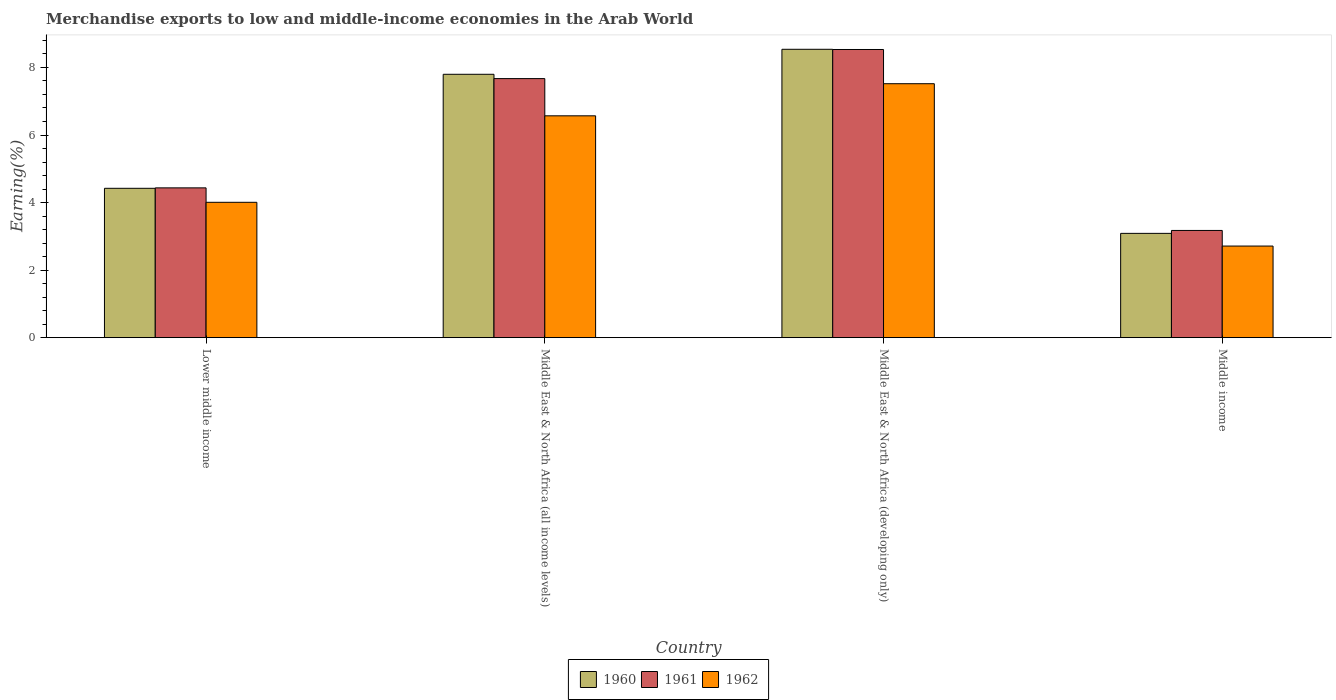How many different coloured bars are there?
Provide a succinct answer. 3. Are the number of bars per tick equal to the number of legend labels?
Your answer should be compact. Yes. Are the number of bars on each tick of the X-axis equal?
Give a very brief answer. Yes. What is the label of the 4th group of bars from the left?
Keep it short and to the point. Middle income. What is the percentage of amount earned from merchandise exports in 1961 in Middle income?
Offer a very short reply. 3.17. Across all countries, what is the maximum percentage of amount earned from merchandise exports in 1960?
Offer a very short reply. 8.54. Across all countries, what is the minimum percentage of amount earned from merchandise exports in 1961?
Give a very brief answer. 3.17. In which country was the percentage of amount earned from merchandise exports in 1961 maximum?
Keep it short and to the point. Middle East & North Africa (developing only). In which country was the percentage of amount earned from merchandise exports in 1960 minimum?
Provide a short and direct response. Middle income. What is the total percentage of amount earned from merchandise exports in 1961 in the graph?
Make the answer very short. 23.81. What is the difference between the percentage of amount earned from merchandise exports in 1960 in Lower middle income and that in Middle East & North Africa (all income levels)?
Make the answer very short. -3.38. What is the difference between the percentage of amount earned from merchandise exports in 1961 in Middle East & North Africa (all income levels) and the percentage of amount earned from merchandise exports in 1962 in Lower middle income?
Your answer should be very brief. 3.66. What is the average percentage of amount earned from merchandise exports in 1962 per country?
Provide a succinct answer. 5.2. What is the difference between the percentage of amount earned from merchandise exports of/in 1961 and percentage of amount earned from merchandise exports of/in 1960 in Middle East & North Africa (developing only)?
Provide a succinct answer. -0.01. In how many countries, is the percentage of amount earned from merchandise exports in 1962 greater than 5.6 %?
Your answer should be very brief. 2. What is the ratio of the percentage of amount earned from merchandise exports in 1962 in Middle East & North Africa (all income levels) to that in Middle East & North Africa (developing only)?
Your answer should be very brief. 0.87. Is the percentage of amount earned from merchandise exports in 1960 in Middle East & North Africa (all income levels) less than that in Middle East & North Africa (developing only)?
Offer a very short reply. Yes. Is the difference between the percentage of amount earned from merchandise exports in 1961 in Middle East & North Africa (developing only) and Middle income greater than the difference between the percentage of amount earned from merchandise exports in 1960 in Middle East & North Africa (developing only) and Middle income?
Your answer should be compact. No. What is the difference between the highest and the second highest percentage of amount earned from merchandise exports in 1961?
Offer a terse response. 4.1. What is the difference between the highest and the lowest percentage of amount earned from merchandise exports in 1960?
Offer a very short reply. 5.45. In how many countries, is the percentage of amount earned from merchandise exports in 1960 greater than the average percentage of amount earned from merchandise exports in 1960 taken over all countries?
Provide a succinct answer. 2. Is the sum of the percentage of amount earned from merchandise exports in 1960 in Middle East & North Africa (all income levels) and Middle income greater than the maximum percentage of amount earned from merchandise exports in 1961 across all countries?
Your answer should be very brief. Yes. What does the 3rd bar from the right in Middle East & North Africa (developing only) represents?
Your answer should be very brief. 1960. How many bars are there?
Ensure brevity in your answer.  12. Are all the bars in the graph horizontal?
Your answer should be compact. No. How many countries are there in the graph?
Keep it short and to the point. 4. What is the difference between two consecutive major ticks on the Y-axis?
Give a very brief answer. 2. Does the graph contain any zero values?
Keep it short and to the point. No. Does the graph contain grids?
Your answer should be compact. No. Where does the legend appear in the graph?
Provide a short and direct response. Bottom center. How many legend labels are there?
Provide a short and direct response. 3. How are the legend labels stacked?
Your response must be concise. Horizontal. What is the title of the graph?
Offer a very short reply. Merchandise exports to low and middle-income economies in the Arab World. Does "1989" appear as one of the legend labels in the graph?
Your answer should be very brief. No. What is the label or title of the X-axis?
Offer a terse response. Country. What is the label or title of the Y-axis?
Your answer should be very brief. Earning(%). What is the Earning(%) of 1960 in Lower middle income?
Offer a very short reply. 4.42. What is the Earning(%) in 1961 in Lower middle income?
Your response must be concise. 4.43. What is the Earning(%) in 1962 in Lower middle income?
Provide a succinct answer. 4.01. What is the Earning(%) of 1960 in Middle East & North Africa (all income levels)?
Give a very brief answer. 7.8. What is the Earning(%) in 1961 in Middle East & North Africa (all income levels)?
Offer a terse response. 7.67. What is the Earning(%) of 1962 in Middle East & North Africa (all income levels)?
Ensure brevity in your answer.  6.57. What is the Earning(%) in 1960 in Middle East & North Africa (developing only)?
Provide a succinct answer. 8.54. What is the Earning(%) in 1961 in Middle East & North Africa (developing only)?
Keep it short and to the point. 8.53. What is the Earning(%) of 1962 in Middle East & North Africa (developing only)?
Give a very brief answer. 7.52. What is the Earning(%) of 1960 in Middle income?
Provide a succinct answer. 3.09. What is the Earning(%) of 1961 in Middle income?
Offer a terse response. 3.17. What is the Earning(%) of 1962 in Middle income?
Make the answer very short. 2.71. Across all countries, what is the maximum Earning(%) in 1960?
Your answer should be very brief. 8.54. Across all countries, what is the maximum Earning(%) in 1961?
Provide a succinct answer. 8.53. Across all countries, what is the maximum Earning(%) in 1962?
Offer a very short reply. 7.52. Across all countries, what is the minimum Earning(%) in 1960?
Provide a succinct answer. 3.09. Across all countries, what is the minimum Earning(%) in 1961?
Make the answer very short. 3.17. Across all countries, what is the minimum Earning(%) in 1962?
Give a very brief answer. 2.71. What is the total Earning(%) of 1960 in the graph?
Ensure brevity in your answer.  23.85. What is the total Earning(%) of 1961 in the graph?
Your answer should be compact. 23.81. What is the total Earning(%) of 1962 in the graph?
Give a very brief answer. 20.81. What is the difference between the Earning(%) in 1960 in Lower middle income and that in Middle East & North Africa (all income levels)?
Give a very brief answer. -3.38. What is the difference between the Earning(%) of 1961 in Lower middle income and that in Middle East & North Africa (all income levels)?
Offer a terse response. -3.23. What is the difference between the Earning(%) of 1962 in Lower middle income and that in Middle East & North Africa (all income levels)?
Offer a very short reply. -2.56. What is the difference between the Earning(%) of 1960 in Lower middle income and that in Middle East & North Africa (developing only)?
Offer a terse response. -4.12. What is the difference between the Earning(%) of 1961 in Lower middle income and that in Middle East & North Africa (developing only)?
Give a very brief answer. -4.1. What is the difference between the Earning(%) of 1962 in Lower middle income and that in Middle East & North Africa (developing only)?
Your answer should be compact. -3.51. What is the difference between the Earning(%) of 1960 in Lower middle income and that in Middle income?
Your answer should be compact. 1.33. What is the difference between the Earning(%) in 1961 in Lower middle income and that in Middle income?
Provide a short and direct response. 1.26. What is the difference between the Earning(%) in 1962 in Lower middle income and that in Middle income?
Your answer should be very brief. 1.3. What is the difference between the Earning(%) of 1960 in Middle East & North Africa (all income levels) and that in Middle East & North Africa (developing only)?
Your answer should be very brief. -0.74. What is the difference between the Earning(%) in 1961 in Middle East & North Africa (all income levels) and that in Middle East & North Africa (developing only)?
Your answer should be very brief. -0.86. What is the difference between the Earning(%) of 1962 in Middle East & North Africa (all income levels) and that in Middle East & North Africa (developing only)?
Make the answer very short. -0.95. What is the difference between the Earning(%) in 1960 in Middle East & North Africa (all income levels) and that in Middle income?
Offer a terse response. 4.71. What is the difference between the Earning(%) of 1961 in Middle East & North Africa (all income levels) and that in Middle income?
Give a very brief answer. 4.5. What is the difference between the Earning(%) of 1962 in Middle East & North Africa (all income levels) and that in Middle income?
Your response must be concise. 3.86. What is the difference between the Earning(%) in 1960 in Middle East & North Africa (developing only) and that in Middle income?
Provide a short and direct response. 5.45. What is the difference between the Earning(%) in 1961 in Middle East & North Africa (developing only) and that in Middle income?
Offer a very short reply. 5.36. What is the difference between the Earning(%) in 1962 in Middle East & North Africa (developing only) and that in Middle income?
Your answer should be very brief. 4.81. What is the difference between the Earning(%) of 1960 in Lower middle income and the Earning(%) of 1961 in Middle East & North Africa (all income levels)?
Offer a terse response. -3.25. What is the difference between the Earning(%) in 1960 in Lower middle income and the Earning(%) in 1962 in Middle East & North Africa (all income levels)?
Ensure brevity in your answer.  -2.15. What is the difference between the Earning(%) in 1961 in Lower middle income and the Earning(%) in 1962 in Middle East & North Africa (all income levels)?
Offer a terse response. -2.13. What is the difference between the Earning(%) in 1960 in Lower middle income and the Earning(%) in 1961 in Middle East & North Africa (developing only)?
Your response must be concise. -4.11. What is the difference between the Earning(%) in 1960 in Lower middle income and the Earning(%) in 1962 in Middle East & North Africa (developing only)?
Keep it short and to the point. -3.1. What is the difference between the Earning(%) in 1961 in Lower middle income and the Earning(%) in 1962 in Middle East & North Africa (developing only)?
Your response must be concise. -3.08. What is the difference between the Earning(%) in 1960 in Lower middle income and the Earning(%) in 1961 in Middle income?
Make the answer very short. 1.25. What is the difference between the Earning(%) of 1960 in Lower middle income and the Earning(%) of 1962 in Middle income?
Give a very brief answer. 1.71. What is the difference between the Earning(%) of 1961 in Lower middle income and the Earning(%) of 1962 in Middle income?
Offer a terse response. 1.72. What is the difference between the Earning(%) in 1960 in Middle East & North Africa (all income levels) and the Earning(%) in 1961 in Middle East & North Africa (developing only)?
Give a very brief answer. -0.73. What is the difference between the Earning(%) of 1960 in Middle East & North Africa (all income levels) and the Earning(%) of 1962 in Middle East & North Africa (developing only)?
Offer a very short reply. 0.28. What is the difference between the Earning(%) in 1961 in Middle East & North Africa (all income levels) and the Earning(%) in 1962 in Middle East & North Africa (developing only)?
Offer a terse response. 0.15. What is the difference between the Earning(%) in 1960 in Middle East & North Africa (all income levels) and the Earning(%) in 1961 in Middle income?
Your response must be concise. 4.62. What is the difference between the Earning(%) of 1960 in Middle East & North Africa (all income levels) and the Earning(%) of 1962 in Middle income?
Offer a very short reply. 5.09. What is the difference between the Earning(%) of 1961 in Middle East & North Africa (all income levels) and the Earning(%) of 1962 in Middle income?
Your answer should be very brief. 4.96. What is the difference between the Earning(%) in 1960 in Middle East & North Africa (developing only) and the Earning(%) in 1961 in Middle income?
Offer a very short reply. 5.36. What is the difference between the Earning(%) in 1960 in Middle East & North Africa (developing only) and the Earning(%) in 1962 in Middle income?
Ensure brevity in your answer.  5.83. What is the difference between the Earning(%) in 1961 in Middle East & North Africa (developing only) and the Earning(%) in 1962 in Middle income?
Provide a short and direct response. 5.82. What is the average Earning(%) in 1960 per country?
Offer a very short reply. 5.96. What is the average Earning(%) of 1961 per country?
Ensure brevity in your answer.  5.95. What is the average Earning(%) in 1962 per country?
Make the answer very short. 5.2. What is the difference between the Earning(%) of 1960 and Earning(%) of 1961 in Lower middle income?
Give a very brief answer. -0.01. What is the difference between the Earning(%) of 1960 and Earning(%) of 1962 in Lower middle income?
Give a very brief answer. 0.41. What is the difference between the Earning(%) of 1961 and Earning(%) of 1962 in Lower middle income?
Offer a terse response. 0.43. What is the difference between the Earning(%) in 1960 and Earning(%) in 1961 in Middle East & North Africa (all income levels)?
Provide a short and direct response. 0.13. What is the difference between the Earning(%) of 1960 and Earning(%) of 1962 in Middle East & North Africa (all income levels)?
Make the answer very short. 1.23. What is the difference between the Earning(%) of 1961 and Earning(%) of 1962 in Middle East & North Africa (all income levels)?
Give a very brief answer. 1.1. What is the difference between the Earning(%) of 1960 and Earning(%) of 1961 in Middle East & North Africa (developing only)?
Make the answer very short. 0.01. What is the difference between the Earning(%) in 1960 and Earning(%) in 1962 in Middle East & North Africa (developing only)?
Make the answer very short. 1.02. What is the difference between the Earning(%) of 1961 and Earning(%) of 1962 in Middle East & North Africa (developing only)?
Give a very brief answer. 1.01. What is the difference between the Earning(%) in 1960 and Earning(%) in 1961 in Middle income?
Make the answer very short. -0.09. What is the difference between the Earning(%) in 1960 and Earning(%) in 1962 in Middle income?
Provide a short and direct response. 0.38. What is the difference between the Earning(%) of 1961 and Earning(%) of 1962 in Middle income?
Provide a short and direct response. 0.46. What is the ratio of the Earning(%) of 1960 in Lower middle income to that in Middle East & North Africa (all income levels)?
Provide a succinct answer. 0.57. What is the ratio of the Earning(%) of 1961 in Lower middle income to that in Middle East & North Africa (all income levels)?
Provide a succinct answer. 0.58. What is the ratio of the Earning(%) in 1962 in Lower middle income to that in Middle East & North Africa (all income levels)?
Make the answer very short. 0.61. What is the ratio of the Earning(%) of 1960 in Lower middle income to that in Middle East & North Africa (developing only)?
Provide a succinct answer. 0.52. What is the ratio of the Earning(%) in 1961 in Lower middle income to that in Middle East & North Africa (developing only)?
Ensure brevity in your answer.  0.52. What is the ratio of the Earning(%) of 1962 in Lower middle income to that in Middle East & North Africa (developing only)?
Your response must be concise. 0.53. What is the ratio of the Earning(%) in 1960 in Lower middle income to that in Middle income?
Your answer should be compact. 1.43. What is the ratio of the Earning(%) of 1961 in Lower middle income to that in Middle income?
Provide a short and direct response. 1.4. What is the ratio of the Earning(%) in 1962 in Lower middle income to that in Middle income?
Keep it short and to the point. 1.48. What is the ratio of the Earning(%) in 1960 in Middle East & North Africa (all income levels) to that in Middle East & North Africa (developing only)?
Your answer should be compact. 0.91. What is the ratio of the Earning(%) in 1961 in Middle East & North Africa (all income levels) to that in Middle East & North Africa (developing only)?
Make the answer very short. 0.9. What is the ratio of the Earning(%) in 1962 in Middle East & North Africa (all income levels) to that in Middle East & North Africa (developing only)?
Give a very brief answer. 0.87. What is the ratio of the Earning(%) in 1960 in Middle East & North Africa (all income levels) to that in Middle income?
Offer a terse response. 2.53. What is the ratio of the Earning(%) in 1961 in Middle East & North Africa (all income levels) to that in Middle income?
Provide a short and direct response. 2.42. What is the ratio of the Earning(%) in 1962 in Middle East & North Africa (all income levels) to that in Middle income?
Offer a very short reply. 2.42. What is the ratio of the Earning(%) in 1960 in Middle East & North Africa (developing only) to that in Middle income?
Give a very brief answer. 2.76. What is the ratio of the Earning(%) in 1961 in Middle East & North Africa (developing only) to that in Middle income?
Provide a succinct answer. 2.69. What is the ratio of the Earning(%) in 1962 in Middle East & North Africa (developing only) to that in Middle income?
Provide a succinct answer. 2.77. What is the difference between the highest and the second highest Earning(%) in 1960?
Your answer should be very brief. 0.74. What is the difference between the highest and the second highest Earning(%) in 1961?
Make the answer very short. 0.86. What is the difference between the highest and the second highest Earning(%) in 1962?
Keep it short and to the point. 0.95. What is the difference between the highest and the lowest Earning(%) of 1960?
Offer a very short reply. 5.45. What is the difference between the highest and the lowest Earning(%) in 1961?
Make the answer very short. 5.36. What is the difference between the highest and the lowest Earning(%) of 1962?
Provide a succinct answer. 4.81. 